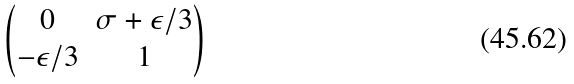Convert formula to latex. <formula><loc_0><loc_0><loc_500><loc_500>\begin{pmatrix} 0 & \sigma + \epsilon / 3 \\ - \epsilon / 3 & 1 \end{pmatrix}</formula> 